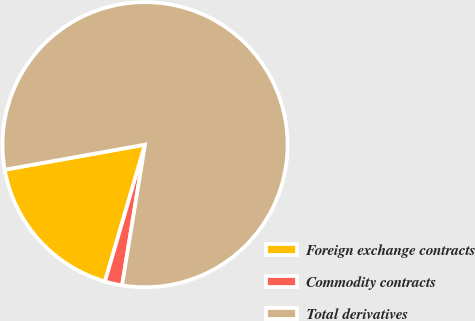Convert chart to OTSL. <chart><loc_0><loc_0><loc_500><loc_500><pie_chart><fcel>Foreign exchange contracts<fcel>Commodity contracts<fcel>Total derivatives<nl><fcel>17.65%<fcel>1.96%<fcel>80.39%<nl></chart> 